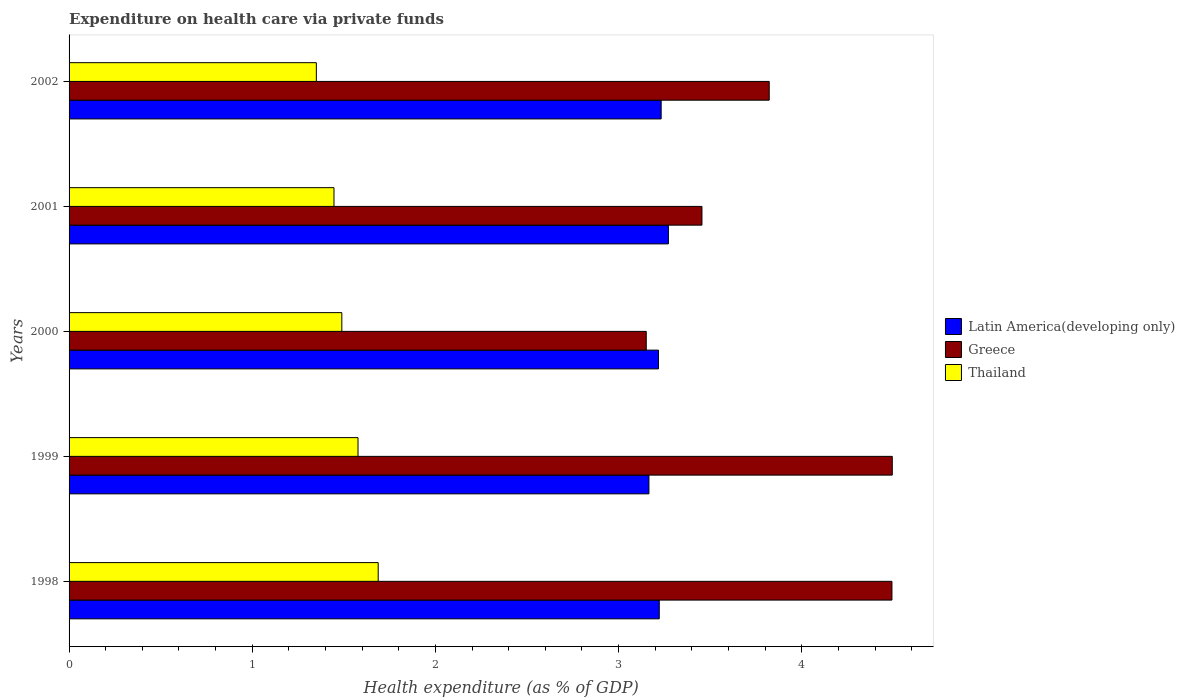How many groups of bars are there?
Your answer should be very brief. 5. Are the number of bars per tick equal to the number of legend labels?
Offer a very short reply. Yes. How many bars are there on the 2nd tick from the top?
Your answer should be very brief. 3. How many bars are there on the 1st tick from the bottom?
Provide a succinct answer. 3. What is the label of the 3rd group of bars from the top?
Make the answer very short. 2000. In how many cases, is the number of bars for a given year not equal to the number of legend labels?
Offer a terse response. 0. What is the expenditure made on health care in Thailand in 1998?
Provide a succinct answer. 1.69. Across all years, what is the maximum expenditure made on health care in Latin America(developing only)?
Your answer should be very brief. 3.27. Across all years, what is the minimum expenditure made on health care in Thailand?
Make the answer very short. 1.35. In which year was the expenditure made on health care in Greece minimum?
Make the answer very short. 2000. What is the total expenditure made on health care in Greece in the graph?
Your answer should be compact. 19.41. What is the difference between the expenditure made on health care in Greece in 1999 and that in 2000?
Ensure brevity in your answer.  1.34. What is the difference between the expenditure made on health care in Thailand in 1998 and the expenditure made on health care in Latin America(developing only) in 2001?
Make the answer very short. -1.58. What is the average expenditure made on health care in Latin America(developing only) per year?
Give a very brief answer. 3.22. In the year 2001, what is the difference between the expenditure made on health care in Greece and expenditure made on health care in Latin America(developing only)?
Give a very brief answer. 0.18. What is the ratio of the expenditure made on health care in Thailand in 1999 to that in 2002?
Offer a terse response. 1.17. What is the difference between the highest and the second highest expenditure made on health care in Thailand?
Offer a terse response. 0.11. What is the difference between the highest and the lowest expenditure made on health care in Thailand?
Ensure brevity in your answer.  0.34. Is the sum of the expenditure made on health care in Greece in 2000 and 2002 greater than the maximum expenditure made on health care in Latin America(developing only) across all years?
Your response must be concise. Yes. What does the 1st bar from the top in 2001 represents?
Give a very brief answer. Thailand. What does the 1st bar from the bottom in 2002 represents?
Provide a succinct answer. Latin America(developing only). Is it the case that in every year, the sum of the expenditure made on health care in Thailand and expenditure made on health care in Greece is greater than the expenditure made on health care in Latin America(developing only)?
Your response must be concise. Yes. How many bars are there?
Keep it short and to the point. 15. Are all the bars in the graph horizontal?
Give a very brief answer. Yes. How many years are there in the graph?
Make the answer very short. 5. What is the difference between two consecutive major ticks on the X-axis?
Provide a short and direct response. 1. Are the values on the major ticks of X-axis written in scientific E-notation?
Keep it short and to the point. No. Does the graph contain any zero values?
Make the answer very short. No. Where does the legend appear in the graph?
Give a very brief answer. Center right. How many legend labels are there?
Provide a short and direct response. 3. How are the legend labels stacked?
Provide a succinct answer. Vertical. What is the title of the graph?
Your answer should be very brief. Expenditure on health care via private funds. Does "Hong Kong" appear as one of the legend labels in the graph?
Offer a very short reply. No. What is the label or title of the X-axis?
Offer a terse response. Health expenditure (as % of GDP). What is the label or title of the Y-axis?
Keep it short and to the point. Years. What is the Health expenditure (as % of GDP) in Latin America(developing only) in 1998?
Your answer should be very brief. 3.22. What is the Health expenditure (as % of GDP) of Greece in 1998?
Make the answer very short. 4.49. What is the Health expenditure (as % of GDP) in Thailand in 1998?
Your answer should be compact. 1.69. What is the Health expenditure (as % of GDP) of Latin America(developing only) in 1999?
Provide a succinct answer. 3.17. What is the Health expenditure (as % of GDP) in Greece in 1999?
Provide a short and direct response. 4.49. What is the Health expenditure (as % of GDP) of Thailand in 1999?
Keep it short and to the point. 1.58. What is the Health expenditure (as % of GDP) of Latin America(developing only) in 2000?
Provide a succinct answer. 3.22. What is the Health expenditure (as % of GDP) of Greece in 2000?
Offer a very short reply. 3.15. What is the Health expenditure (as % of GDP) in Thailand in 2000?
Ensure brevity in your answer.  1.49. What is the Health expenditure (as % of GDP) in Latin America(developing only) in 2001?
Provide a succinct answer. 3.27. What is the Health expenditure (as % of GDP) in Greece in 2001?
Give a very brief answer. 3.45. What is the Health expenditure (as % of GDP) of Thailand in 2001?
Offer a very short reply. 1.45. What is the Health expenditure (as % of GDP) in Latin America(developing only) in 2002?
Make the answer very short. 3.23. What is the Health expenditure (as % of GDP) in Greece in 2002?
Your answer should be compact. 3.82. What is the Health expenditure (as % of GDP) in Thailand in 2002?
Make the answer very short. 1.35. Across all years, what is the maximum Health expenditure (as % of GDP) in Latin America(developing only)?
Offer a very short reply. 3.27. Across all years, what is the maximum Health expenditure (as % of GDP) of Greece?
Your response must be concise. 4.49. Across all years, what is the maximum Health expenditure (as % of GDP) of Thailand?
Your answer should be very brief. 1.69. Across all years, what is the minimum Health expenditure (as % of GDP) in Latin America(developing only)?
Keep it short and to the point. 3.17. Across all years, what is the minimum Health expenditure (as % of GDP) in Greece?
Offer a very short reply. 3.15. Across all years, what is the minimum Health expenditure (as % of GDP) of Thailand?
Offer a terse response. 1.35. What is the total Health expenditure (as % of GDP) of Latin America(developing only) in the graph?
Provide a short and direct response. 16.11. What is the total Health expenditure (as % of GDP) in Greece in the graph?
Offer a very short reply. 19.41. What is the total Health expenditure (as % of GDP) in Thailand in the graph?
Your answer should be compact. 7.55. What is the difference between the Health expenditure (as % of GDP) in Latin America(developing only) in 1998 and that in 1999?
Offer a very short reply. 0.06. What is the difference between the Health expenditure (as % of GDP) in Greece in 1998 and that in 1999?
Your answer should be compact. -0. What is the difference between the Health expenditure (as % of GDP) in Thailand in 1998 and that in 1999?
Provide a short and direct response. 0.11. What is the difference between the Health expenditure (as % of GDP) of Latin America(developing only) in 1998 and that in 2000?
Ensure brevity in your answer.  0. What is the difference between the Health expenditure (as % of GDP) in Greece in 1998 and that in 2000?
Your answer should be compact. 1.34. What is the difference between the Health expenditure (as % of GDP) in Thailand in 1998 and that in 2000?
Give a very brief answer. 0.2. What is the difference between the Health expenditure (as % of GDP) of Latin America(developing only) in 1998 and that in 2001?
Give a very brief answer. -0.05. What is the difference between the Health expenditure (as % of GDP) of Greece in 1998 and that in 2001?
Provide a succinct answer. 1.04. What is the difference between the Health expenditure (as % of GDP) of Thailand in 1998 and that in 2001?
Keep it short and to the point. 0.24. What is the difference between the Health expenditure (as % of GDP) of Latin America(developing only) in 1998 and that in 2002?
Provide a short and direct response. -0.01. What is the difference between the Health expenditure (as % of GDP) in Greece in 1998 and that in 2002?
Give a very brief answer. 0.67. What is the difference between the Health expenditure (as % of GDP) in Thailand in 1998 and that in 2002?
Your answer should be compact. 0.34. What is the difference between the Health expenditure (as % of GDP) in Latin America(developing only) in 1999 and that in 2000?
Offer a very short reply. -0.05. What is the difference between the Health expenditure (as % of GDP) in Greece in 1999 and that in 2000?
Ensure brevity in your answer.  1.34. What is the difference between the Health expenditure (as % of GDP) in Thailand in 1999 and that in 2000?
Your answer should be very brief. 0.09. What is the difference between the Health expenditure (as % of GDP) in Latin America(developing only) in 1999 and that in 2001?
Your answer should be compact. -0.11. What is the difference between the Health expenditure (as % of GDP) of Greece in 1999 and that in 2001?
Give a very brief answer. 1.04. What is the difference between the Health expenditure (as % of GDP) in Thailand in 1999 and that in 2001?
Ensure brevity in your answer.  0.13. What is the difference between the Health expenditure (as % of GDP) in Latin America(developing only) in 1999 and that in 2002?
Ensure brevity in your answer.  -0.07. What is the difference between the Health expenditure (as % of GDP) of Greece in 1999 and that in 2002?
Offer a terse response. 0.67. What is the difference between the Health expenditure (as % of GDP) in Thailand in 1999 and that in 2002?
Offer a very short reply. 0.23. What is the difference between the Health expenditure (as % of GDP) in Latin America(developing only) in 2000 and that in 2001?
Your response must be concise. -0.05. What is the difference between the Health expenditure (as % of GDP) in Greece in 2000 and that in 2001?
Offer a very short reply. -0.3. What is the difference between the Health expenditure (as % of GDP) of Thailand in 2000 and that in 2001?
Give a very brief answer. 0.04. What is the difference between the Health expenditure (as % of GDP) in Latin America(developing only) in 2000 and that in 2002?
Ensure brevity in your answer.  -0.01. What is the difference between the Health expenditure (as % of GDP) in Greece in 2000 and that in 2002?
Keep it short and to the point. -0.67. What is the difference between the Health expenditure (as % of GDP) of Thailand in 2000 and that in 2002?
Offer a very short reply. 0.14. What is the difference between the Health expenditure (as % of GDP) of Latin America(developing only) in 2001 and that in 2002?
Provide a short and direct response. 0.04. What is the difference between the Health expenditure (as % of GDP) of Greece in 2001 and that in 2002?
Your response must be concise. -0.37. What is the difference between the Health expenditure (as % of GDP) in Thailand in 2001 and that in 2002?
Offer a very short reply. 0.1. What is the difference between the Health expenditure (as % of GDP) in Latin America(developing only) in 1998 and the Health expenditure (as % of GDP) in Greece in 1999?
Offer a terse response. -1.27. What is the difference between the Health expenditure (as % of GDP) of Latin America(developing only) in 1998 and the Health expenditure (as % of GDP) of Thailand in 1999?
Offer a terse response. 1.64. What is the difference between the Health expenditure (as % of GDP) in Greece in 1998 and the Health expenditure (as % of GDP) in Thailand in 1999?
Ensure brevity in your answer.  2.91. What is the difference between the Health expenditure (as % of GDP) in Latin America(developing only) in 1998 and the Health expenditure (as % of GDP) in Greece in 2000?
Give a very brief answer. 0.07. What is the difference between the Health expenditure (as % of GDP) in Latin America(developing only) in 1998 and the Health expenditure (as % of GDP) in Thailand in 2000?
Your answer should be compact. 1.73. What is the difference between the Health expenditure (as % of GDP) of Greece in 1998 and the Health expenditure (as % of GDP) of Thailand in 2000?
Provide a succinct answer. 3. What is the difference between the Health expenditure (as % of GDP) in Latin America(developing only) in 1998 and the Health expenditure (as % of GDP) in Greece in 2001?
Make the answer very short. -0.23. What is the difference between the Health expenditure (as % of GDP) in Latin America(developing only) in 1998 and the Health expenditure (as % of GDP) in Thailand in 2001?
Your response must be concise. 1.78. What is the difference between the Health expenditure (as % of GDP) in Greece in 1998 and the Health expenditure (as % of GDP) in Thailand in 2001?
Offer a terse response. 3.05. What is the difference between the Health expenditure (as % of GDP) of Latin America(developing only) in 1998 and the Health expenditure (as % of GDP) of Greece in 2002?
Provide a short and direct response. -0.6. What is the difference between the Health expenditure (as % of GDP) in Latin America(developing only) in 1998 and the Health expenditure (as % of GDP) in Thailand in 2002?
Give a very brief answer. 1.87. What is the difference between the Health expenditure (as % of GDP) in Greece in 1998 and the Health expenditure (as % of GDP) in Thailand in 2002?
Give a very brief answer. 3.14. What is the difference between the Health expenditure (as % of GDP) in Latin America(developing only) in 1999 and the Health expenditure (as % of GDP) in Greece in 2000?
Make the answer very short. 0.01. What is the difference between the Health expenditure (as % of GDP) of Latin America(developing only) in 1999 and the Health expenditure (as % of GDP) of Thailand in 2000?
Provide a short and direct response. 1.68. What is the difference between the Health expenditure (as % of GDP) in Greece in 1999 and the Health expenditure (as % of GDP) in Thailand in 2000?
Your answer should be compact. 3. What is the difference between the Health expenditure (as % of GDP) of Latin America(developing only) in 1999 and the Health expenditure (as % of GDP) of Greece in 2001?
Ensure brevity in your answer.  -0.29. What is the difference between the Health expenditure (as % of GDP) in Latin America(developing only) in 1999 and the Health expenditure (as % of GDP) in Thailand in 2001?
Keep it short and to the point. 1.72. What is the difference between the Health expenditure (as % of GDP) of Greece in 1999 and the Health expenditure (as % of GDP) of Thailand in 2001?
Your answer should be compact. 3.05. What is the difference between the Health expenditure (as % of GDP) of Latin America(developing only) in 1999 and the Health expenditure (as % of GDP) of Greece in 2002?
Your answer should be very brief. -0.66. What is the difference between the Health expenditure (as % of GDP) of Latin America(developing only) in 1999 and the Health expenditure (as % of GDP) of Thailand in 2002?
Provide a short and direct response. 1.82. What is the difference between the Health expenditure (as % of GDP) of Greece in 1999 and the Health expenditure (as % of GDP) of Thailand in 2002?
Your answer should be compact. 3.14. What is the difference between the Health expenditure (as % of GDP) of Latin America(developing only) in 2000 and the Health expenditure (as % of GDP) of Greece in 2001?
Offer a terse response. -0.24. What is the difference between the Health expenditure (as % of GDP) of Latin America(developing only) in 2000 and the Health expenditure (as % of GDP) of Thailand in 2001?
Offer a terse response. 1.77. What is the difference between the Health expenditure (as % of GDP) in Greece in 2000 and the Health expenditure (as % of GDP) in Thailand in 2001?
Offer a very short reply. 1.7. What is the difference between the Health expenditure (as % of GDP) of Latin America(developing only) in 2000 and the Health expenditure (as % of GDP) of Greece in 2002?
Provide a short and direct response. -0.6. What is the difference between the Health expenditure (as % of GDP) of Latin America(developing only) in 2000 and the Health expenditure (as % of GDP) of Thailand in 2002?
Your response must be concise. 1.87. What is the difference between the Health expenditure (as % of GDP) of Greece in 2000 and the Health expenditure (as % of GDP) of Thailand in 2002?
Offer a terse response. 1.8. What is the difference between the Health expenditure (as % of GDP) of Latin America(developing only) in 2001 and the Health expenditure (as % of GDP) of Greece in 2002?
Provide a succinct answer. -0.55. What is the difference between the Health expenditure (as % of GDP) in Latin America(developing only) in 2001 and the Health expenditure (as % of GDP) in Thailand in 2002?
Keep it short and to the point. 1.92. What is the difference between the Health expenditure (as % of GDP) of Greece in 2001 and the Health expenditure (as % of GDP) of Thailand in 2002?
Your response must be concise. 2.11. What is the average Health expenditure (as % of GDP) in Latin America(developing only) per year?
Provide a short and direct response. 3.22. What is the average Health expenditure (as % of GDP) in Greece per year?
Ensure brevity in your answer.  3.88. What is the average Health expenditure (as % of GDP) of Thailand per year?
Offer a terse response. 1.51. In the year 1998, what is the difference between the Health expenditure (as % of GDP) of Latin America(developing only) and Health expenditure (as % of GDP) of Greece?
Give a very brief answer. -1.27. In the year 1998, what is the difference between the Health expenditure (as % of GDP) in Latin America(developing only) and Health expenditure (as % of GDP) in Thailand?
Provide a short and direct response. 1.53. In the year 1998, what is the difference between the Health expenditure (as % of GDP) of Greece and Health expenditure (as % of GDP) of Thailand?
Ensure brevity in your answer.  2.8. In the year 1999, what is the difference between the Health expenditure (as % of GDP) of Latin America(developing only) and Health expenditure (as % of GDP) of Greece?
Provide a succinct answer. -1.33. In the year 1999, what is the difference between the Health expenditure (as % of GDP) of Latin America(developing only) and Health expenditure (as % of GDP) of Thailand?
Offer a terse response. 1.59. In the year 1999, what is the difference between the Health expenditure (as % of GDP) of Greece and Health expenditure (as % of GDP) of Thailand?
Ensure brevity in your answer.  2.92. In the year 2000, what is the difference between the Health expenditure (as % of GDP) in Latin America(developing only) and Health expenditure (as % of GDP) in Greece?
Offer a terse response. 0.07. In the year 2000, what is the difference between the Health expenditure (as % of GDP) in Latin America(developing only) and Health expenditure (as % of GDP) in Thailand?
Offer a terse response. 1.73. In the year 2000, what is the difference between the Health expenditure (as % of GDP) of Greece and Health expenditure (as % of GDP) of Thailand?
Give a very brief answer. 1.66. In the year 2001, what is the difference between the Health expenditure (as % of GDP) of Latin America(developing only) and Health expenditure (as % of GDP) of Greece?
Offer a terse response. -0.18. In the year 2001, what is the difference between the Health expenditure (as % of GDP) of Latin America(developing only) and Health expenditure (as % of GDP) of Thailand?
Make the answer very short. 1.83. In the year 2001, what is the difference between the Health expenditure (as % of GDP) of Greece and Health expenditure (as % of GDP) of Thailand?
Your answer should be very brief. 2.01. In the year 2002, what is the difference between the Health expenditure (as % of GDP) in Latin America(developing only) and Health expenditure (as % of GDP) in Greece?
Give a very brief answer. -0.59. In the year 2002, what is the difference between the Health expenditure (as % of GDP) in Latin America(developing only) and Health expenditure (as % of GDP) in Thailand?
Offer a terse response. 1.88. In the year 2002, what is the difference between the Health expenditure (as % of GDP) of Greece and Health expenditure (as % of GDP) of Thailand?
Provide a succinct answer. 2.47. What is the ratio of the Health expenditure (as % of GDP) of Latin America(developing only) in 1998 to that in 1999?
Your response must be concise. 1.02. What is the ratio of the Health expenditure (as % of GDP) of Greece in 1998 to that in 1999?
Provide a short and direct response. 1. What is the ratio of the Health expenditure (as % of GDP) of Thailand in 1998 to that in 1999?
Offer a very short reply. 1.07. What is the ratio of the Health expenditure (as % of GDP) in Latin America(developing only) in 1998 to that in 2000?
Ensure brevity in your answer.  1. What is the ratio of the Health expenditure (as % of GDP) in Greece in 1998 to that in 2000?
Keep it short and to the point. 1.43. What is the ratio of the Health expenditure (as % of GDP) in Thailand in 1998 to that in 2000?
Your answer should be very brief. 1.13. What is the ratio of the Health expenditure (as % of GDP) in Latin America(developing only) in 1998 to that in 2001?
Your response must be concise. 0.98. What is the ratio of the Health expenditure (as % of GDP) in Greece in 1998 to that in 2001?
Give a very brief answer. 1.3. What is the ratio of the Health expenditure (as % of GDP) in Thailand in 1998 to that in 2001?
Your response must be concise. 1.17. What is the ratio of the Health expenditure (as % of GDP) of Latin America(developing only) in 1998 to that in 2002?
Your response must be concise. 1. What is the ratio of the Health expenditure (as % of GDP) in Greece in 1998 to that in 2002?
Give a very brief answer. 1.18. What is the ratio of the Health expenditure (as % of GDP) in Thailand in 1998 to that in 2002?
Ensure brevity in your answer.  1.25. What is the ratio of the Health expenditure (as % of GDP) of Latin America(developing only) in 1999 to that in 2000?
Your response must be concise. 0.98. What is the ratio of the Health expenditure (as % of GDP) in Greece in 1999 to that in 2000?
Offer a very short reply. 1.43. What is the ratio of the Health expenditure (as % of GDP) of Thailand in 1999 to that in 2000?
Provide a succinct answer. 1.06. What is the ratio of the Health expenditure (as % of GDP) in Latin America(developing only) in 1999 to that in 2001?
Provide a succinct answer. 0.97. What is the ratio of the Health expenditure (as % of GDP) of Greece in 1999 to that in 2001?
Your response must be concise. 1.3. What is the ratio of the Health expenditure (as % of GDP) in Thailand in 1999 to that in 2001?
Offer a very short reply. 1.09. What is the ratio of the Health expenditure (as % of GDP) of Latin America(developing only) in 1999 to that in 2002?
Provide a succinct answer. 0.98. What is the ratio of the Health expenditure (as % of GDP) of Greece in 1999 to that in 2002?
Your answer should be very brief. 1.18. What is the ratio of the Health expenditure (as % of GDP) of Thailand in 1999 to that in 2002?
Offer a very short reply. 1.17. What is the ratio of the Health expenditure (as % of GDP) of Latin America(developing only) in 2000 to that in 2001?
Give a very brief answer. 0.98. What is the ratio of the Health expenditure (as % of GDP) of Greece in 2000 to that in 2001?
Ensure brevity in your answer.  0.91. What is the ratio of the Health expenditure (as % of GDP) in Thailand in 2000 to that in 2001?
Provide a succinct answer. 1.03. What is the ratio of the Health expenditure (as % of GDP) in Greece in 2000 to that in 2002?
Ensure brevity in your answer.  0.82. What is the ratio of the Health expenditure (as % of GDP) of Thailand in 2000 to that in 2002?
Keep it short and to the point. 1.1. What is the ratio of the Health expenditure (as % of GDP) of Latin America(developing only) in 2001 to that in 2002?
Ensure brevity in your answer.  1.01. What is the ratio of the Health expenditure (as % of GDP) in Greece in 2001 to that in 2002?
Ensure brevity in your answer.  0.9. What is the ratio of the Health expenditure (as % of GDP) of Thailand in 2001 to that in 2002?
Provide a short and direct response. 1.07. What is the difference between the highest and the second highest Health expenditure (as % of GDP) in Latin America(developing only)?
Your answer should be very brief. 0.04. What is the difference between the highest and the second highest Health expenditure (as % of GDP) of Greece?
Give a very brief answer. 0. What is the difference between the highest and the second highest Health expenditure (as % of GDP) of Thailand?
Offer a very short reply. 0.11. What is the difference between the highest and the lowest Health expenditure (as % of GDP) in Latin America(developing only)?
Ensure brevity in your answer.  0.11. What is the difference between the highest and the lowest Health expenditure (as % of GDP) of Greece?
Provide a short and direct response. 1.34. What is the difference between the highest and the lowest Health expenditure (as % of GDP) in Thailand?
Offer a terse response. 0.34. 